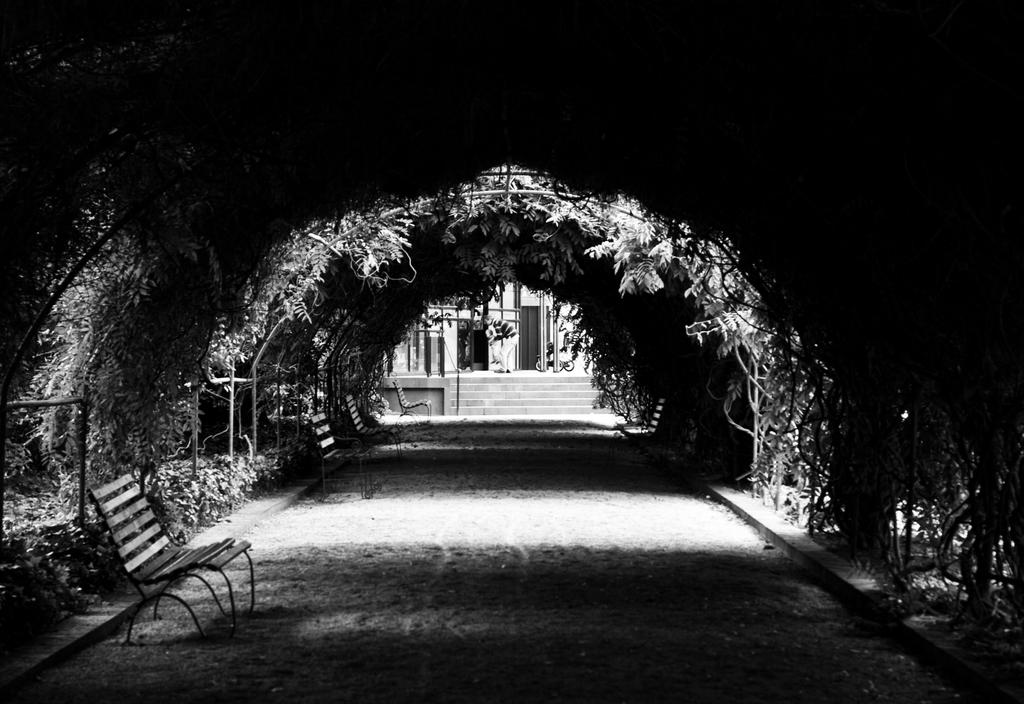What type of seating can be seen in the image? There are benches in the image. What is used to separate or enclose an area in the image? There is a fence in the image. What type of ground surface is visible in the image? There is grass in the image. What type of vegetation is present in the image? There are plants and creepers in the image. What type of structure is present in the image? There is a shed in the image. What type of material is used for the rods in the image? There are metal rods in the image. What architectural feature is present in the image? There are steps in the image. What type of building is visible in the image? There is a building in the image. What can be inferred about the time of day when the image was taken? The image was likely taken during the day, as there is sufficient light to see the details clearly. What type of wood is used to make the garden fence in the image? There is no mention of a garden or wood in the image; it features a fence made of metal rods. What color is the sweater worn by the person in the image? There is no person or sweater present in the image. 